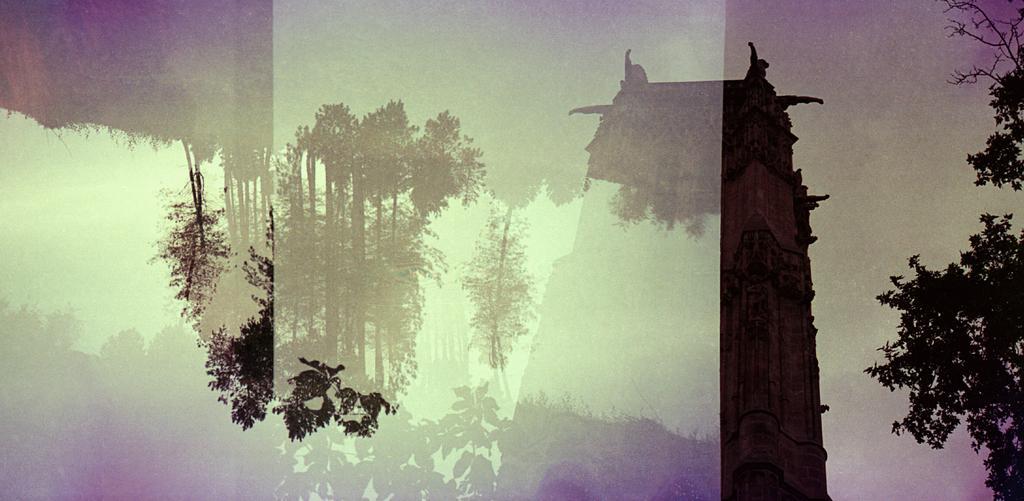Describe this image in one or two sentences. In this picture we can see a building and some trees, there is the sky in the background. 